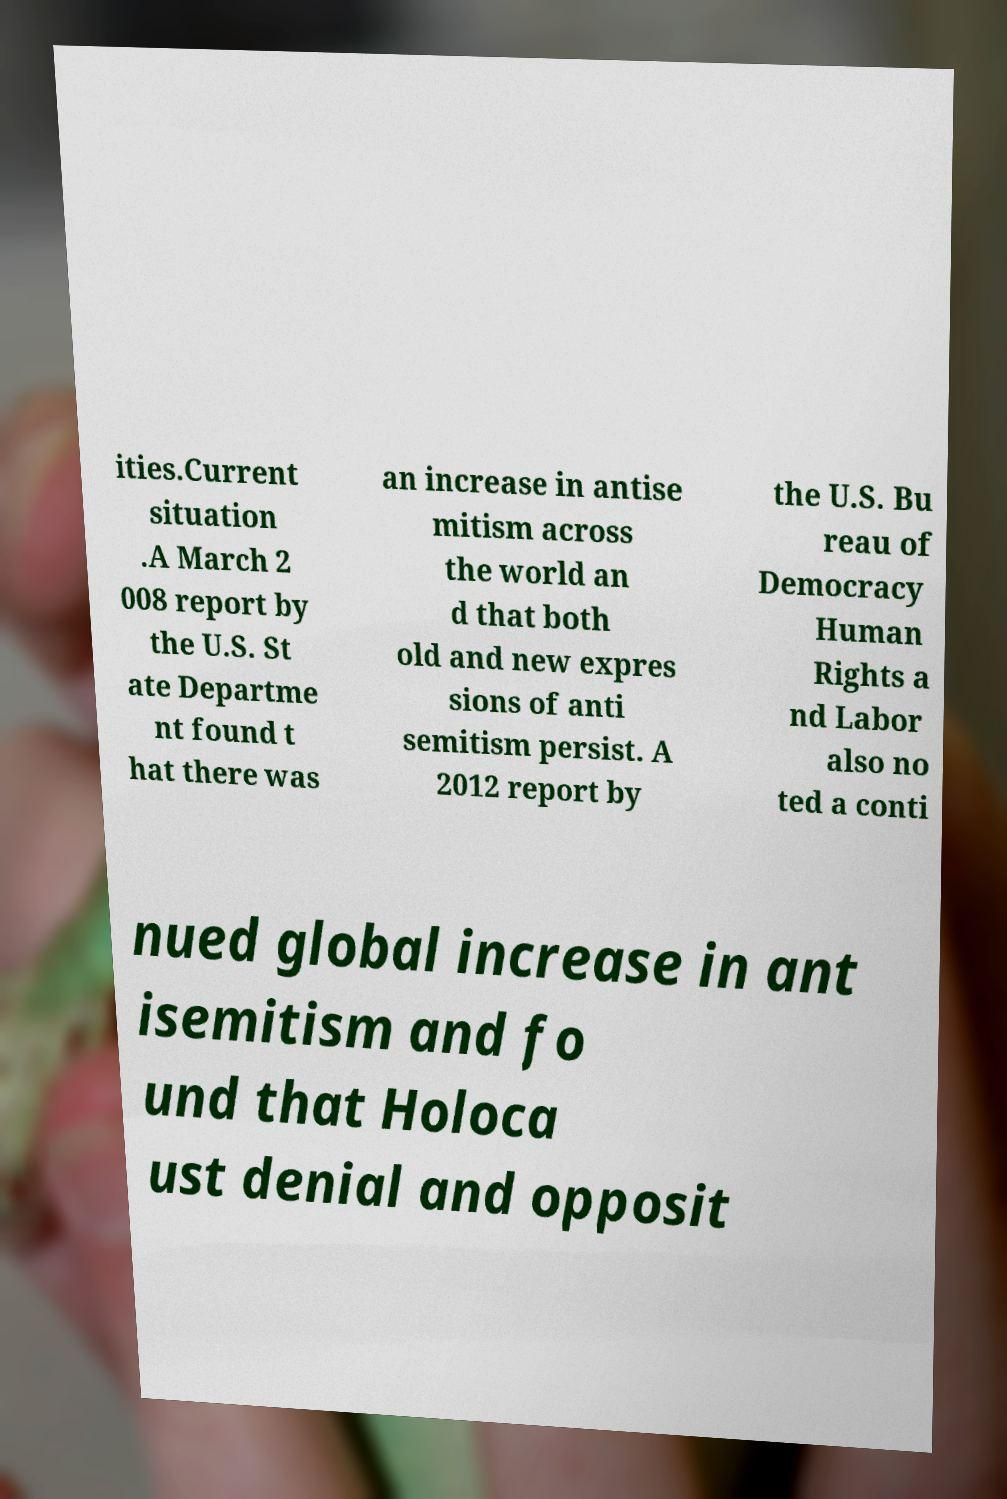For documentation purposes, I need the text within this image transcribed. Could you provide that? ities.Current situation .A March 2 008 report by the U.S. St ate Departme nt found t hat there was an increase in antise mitism across the world an d that both old and new expres sions of anti semitism persist. A 2012 report by the U.S. Bu reau of Democracy Human Rights a nd Labor also no ted a conti nued global increase in ant isemitism and fo und that Holoca ust denial and opposit 